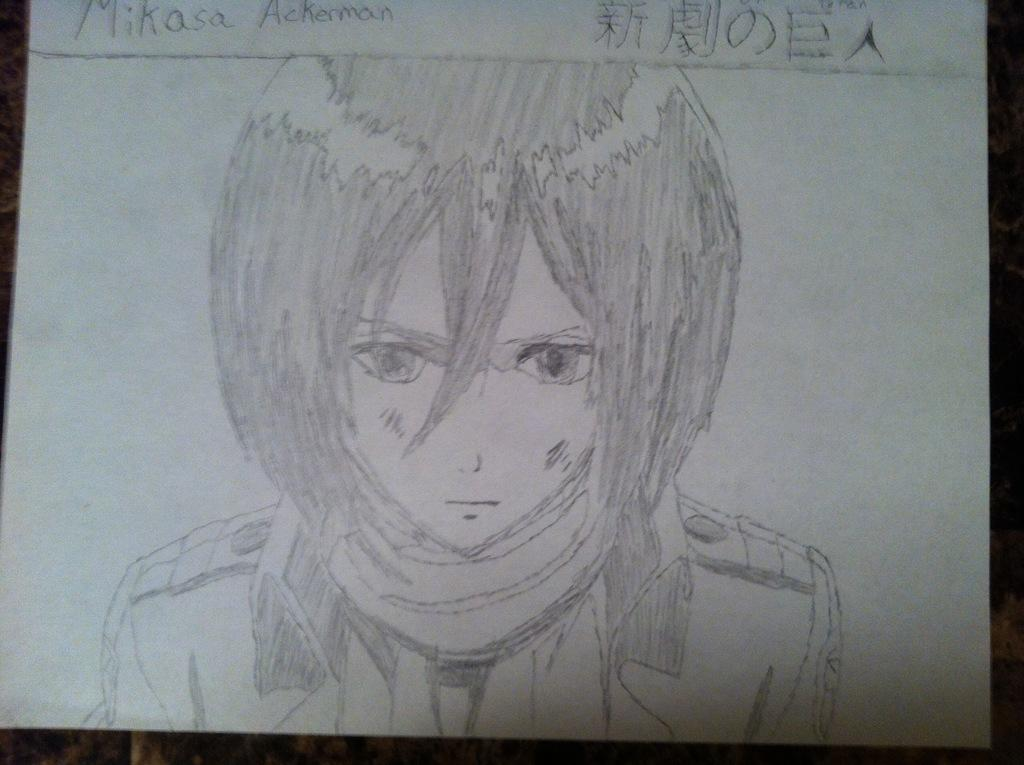What is depicted in the image? The image contains a sketch of a man. What is the background of the sketch? The sketch is drawn on white paper. Is there any text associated with the sketch? Yes, the name of the person is written at the top of the picture. What type of comfort can be seen in the image? There is no comfort depicted in the image, as it features a sketch of a man on white paper with a name written at the top. 